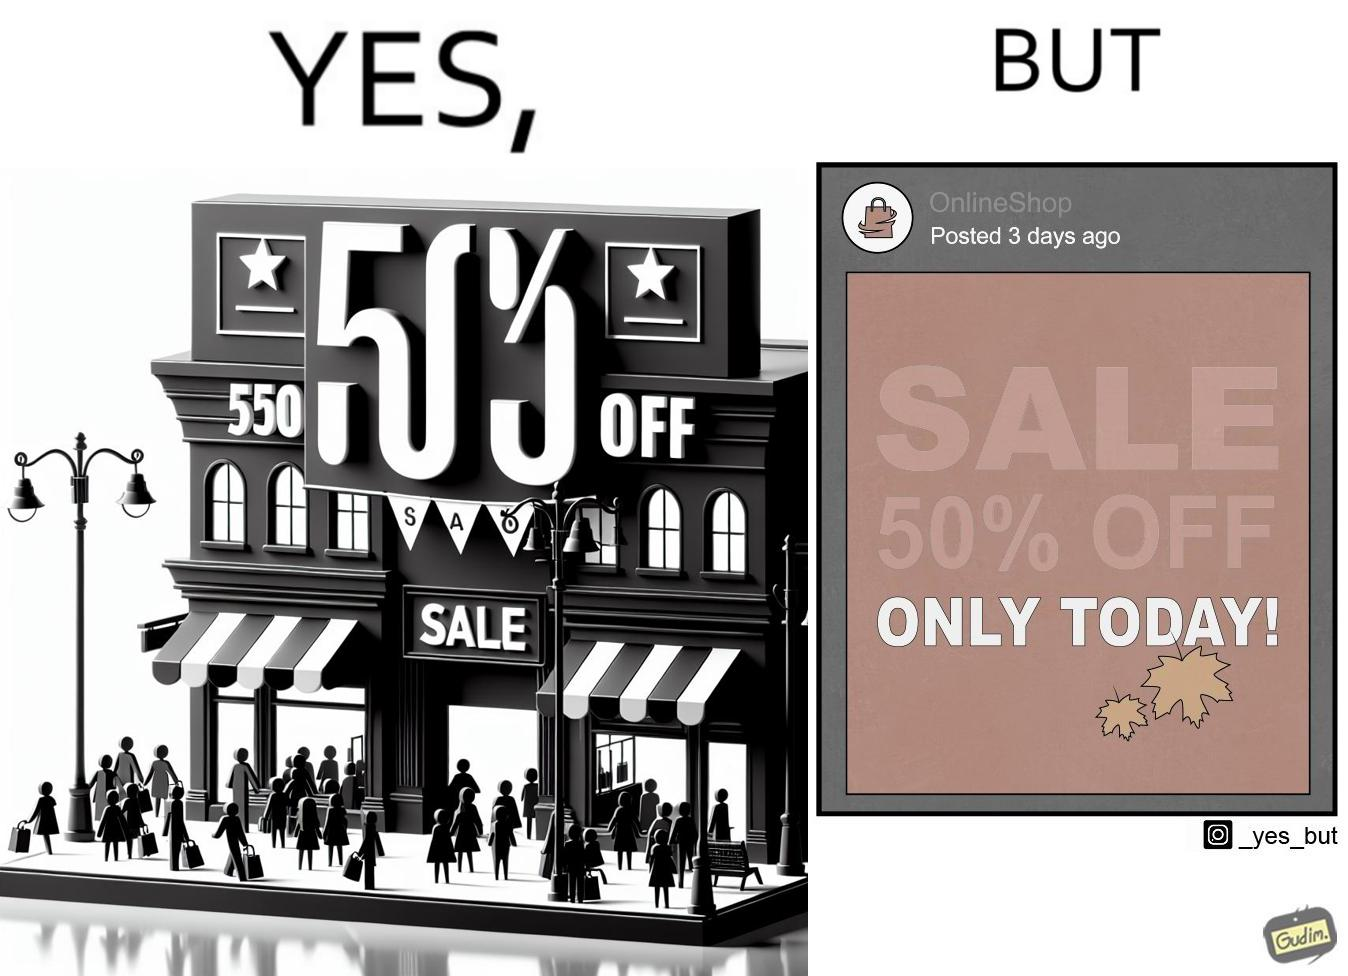What do you see in each half of this image? In the left part of the image: a poster suggesting a sale of 50% off on a particular day In the right part of the image: a post posted by a social media account, named as OnlineShop, 3 days ago showing an image of a poster suggesting a sale of 50% off on a particular day 